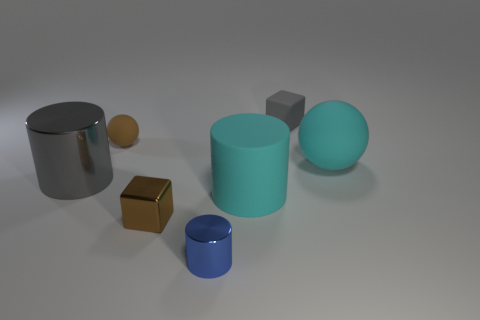Add 2 balls. How many objects exist? 9 Subtract all spheres. How many objects are left? 5 Subtract all tiny gray matte blocks. Subtract all tiny blue metal things. How many objects are left? 5 Add 1 tiny brown rubber objects. How many tiny brown rubber objects are left? 2 Add 4 big shiny cylinders. How many big shiny cylinders exist? 5 Subtract 0 red spheres. How many objects are left? 7 